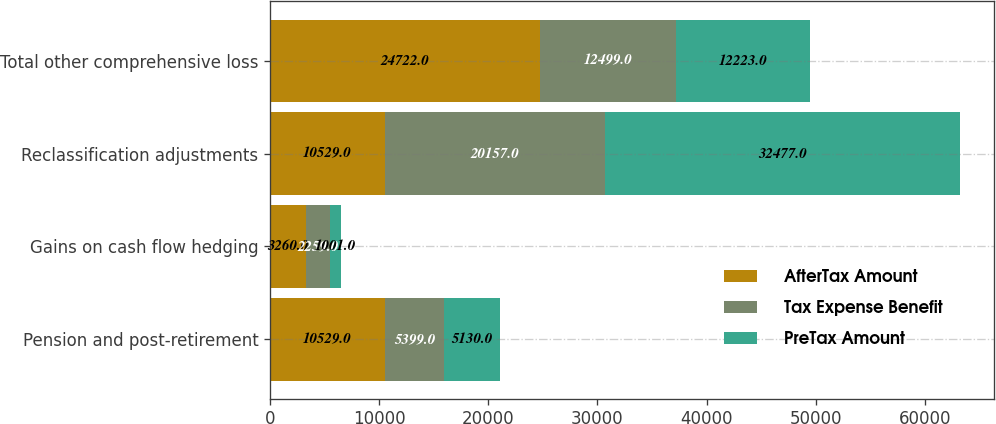Convert chart to OTSL. <chart><loc_0><loc_0><loc_500><loc_500><stacked_bar_chart><ecel><fcel>Pension and post-retirement<fcel>Gains on cash flow hedging<fcel>Reclassification adjustments<fcel>Total other comprehensive loss<nl><fcel>AfterTax Amount<fcel>10529<fcel>3260<fcel>10529<fcel>24722<nl><fcel>Tax Expense Benefit<fcel>5399<fcel>2259<fcel>20157<fcel>12499<nl><fcel>PreTax Amount<fcel>5130<fcel>1001<fcel>32477<fcel>12223<nl></chart> 